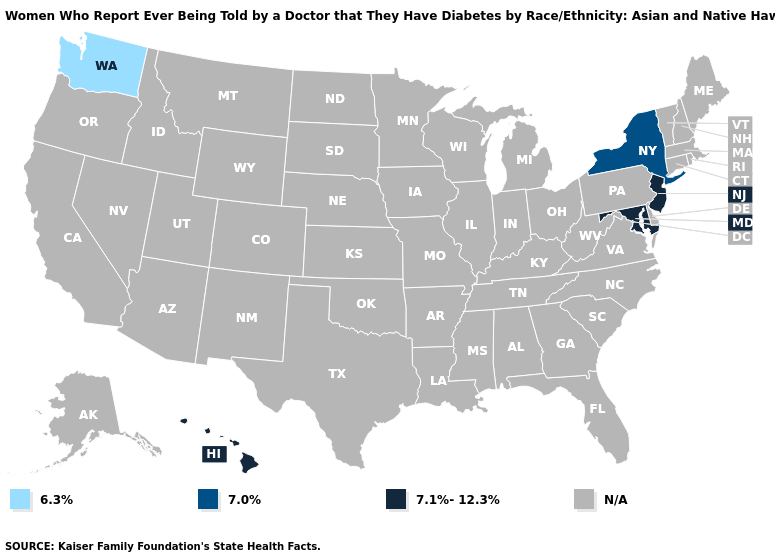Which states have the lowest value in the Northeast?
Quick response, please. New York. What is the lowest value in the USA?
Be succinct. 6.3%. What is the value of Indiana?
Concise answer only. N/A. Name the states that have a value in the range N/A?
Answer briefly. Alabama, Alaska, Arizona, Arkansas, California, Colorado, Connecticut, Delaware, Florida, Georgia, Idaho, Illinois, Indiana, Iowa, Kansas, Kentucky, Louisiana, Maine, Massachusetts, Michigan, Minnesota, Mississippi, Missouri, Montana, Nebraska, Nevada, New Hampshire, New Mexico, North Carolina, North Dakota, Ohio, Oklahoma, Oregon, Pennsylvania, Rhode Island, South Carolina, South Dakota, Tennessee, Texas, Utah, Vermont, Virginia, West Virginia, Wisconsin, Wyoming. Does the map have missing data?
Keep it brief. Yes. What is the lowest value in the USA?
Concise answer only. 6.3%. Name the states that have a value in the range N/A?
Answer briefly. Alabama, Alaska, Arizona, Arkansas, California, Colorado, Connecticut, Delaware, Florida, Georgia, Idaho, Illinois, Indiana, Iowa, Kansas, Kentucky, Louisiana, Maine, Massachusetts, Michigan, Minnesota, Mississippi, Missouri, Montana, Nebraska, Nevada, New Hampshire, New Mexico, North Carolina, North Dakota, Ohio, Oklahoma, Oregon, Pennsylvania, Rhode Island, South Carolina, South Dakota, Tennessee, Texas, Utah, Vermont, Virginia, West Virginia, Wisconsin, Wyoming. Is the legend a continuous bar?
Quick response, please. No. What is the lowest value in the USA?
Write a very short answer. 6.3%. What is the highest value in the USA?
Write a very short answer. 7.1%-12.3%. What is the value of Kansas?
Be succinct. N/A. 